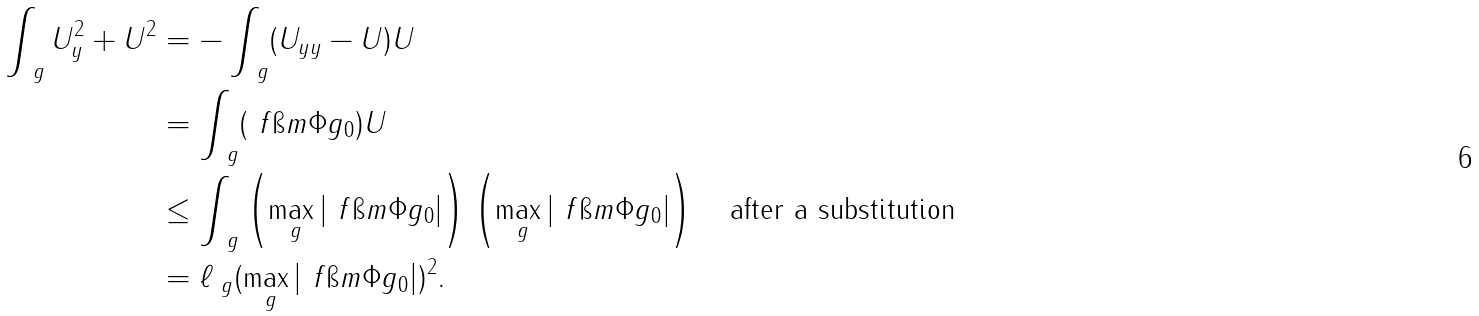<formula> <loc_0><loc_0><loc_500><loc_500>\int _ { \ g } U ^ { 2 } _ { y } + U ^ { 2 } & = - \int _ { \ g } ( U _ { y y } - U ) U \\ & = \int _ { \ g } ( \ f { \i m \Phi } { g _ { 0 } } ) U \\ & \leq \int _ { \ g } \left ( \max _ { \ g } \left | \ f { \i m \Phi } { g _ { 0 } } \right | \right ) \left ( \max _ { \ g } \left | \ f { \i m \Phi } { g _ { 0 } } \right | \right ) \quad \text {after a substitution } \\ & = \ell _ { \ g } ( \max _ { \ g } \left | \ f { \i m \Phi } { g _ { 0 } } \right | ) ^ { 2 } .</formula> 